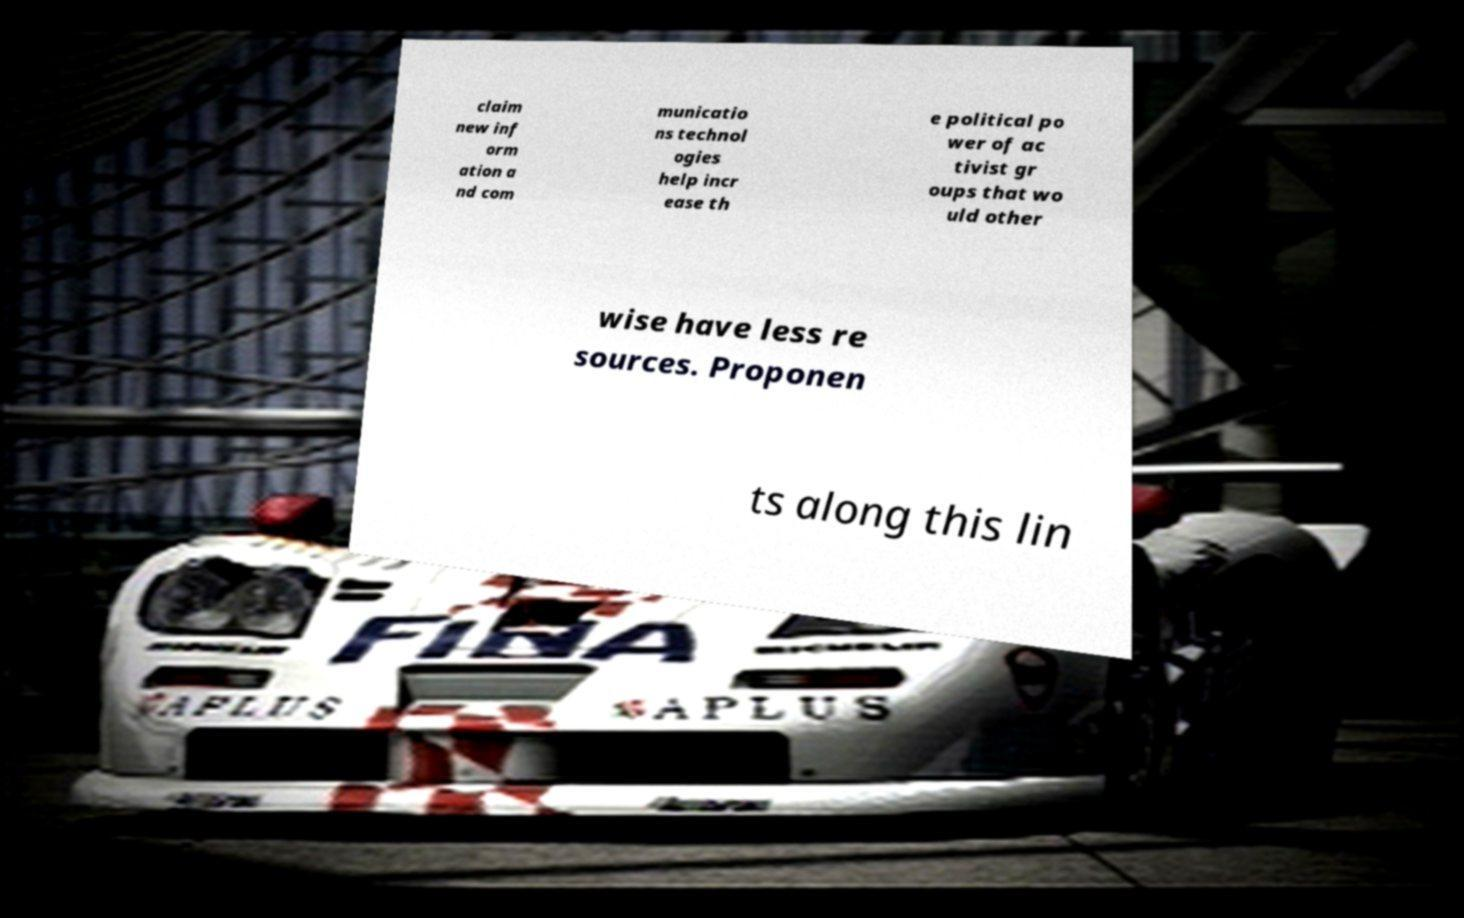Please identify and transcribe the text found in this image. claim new inf orm ation a nd com municatio ns technol ogies help incr ease th e political po wer of ac tivist gr oups that wo uld other wise have less re sources. Proponen ts along this lin 